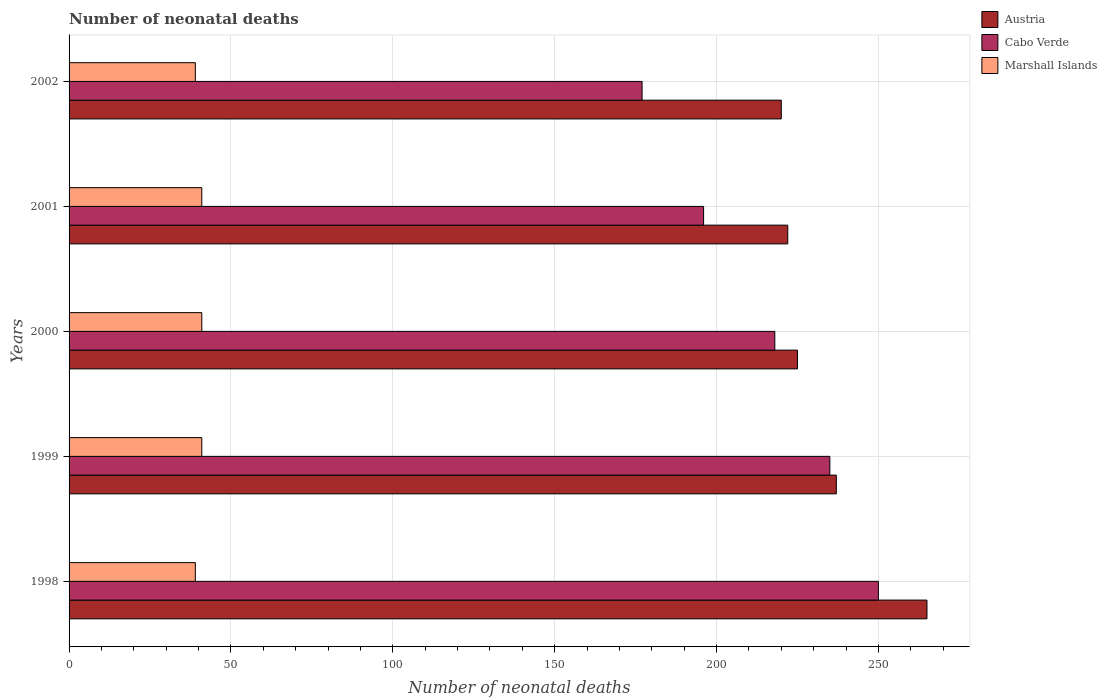How many different coloured bars are there?
Ensure brevity in your answer.  3. Are the number of bars per tick equal to the number of legend labels?
Offer a very short reply. Yes. Are the number of bars on each tick of the Y-axis equal?
Your response must be concise. Yes. How many bars are there on the 2nd tick from the top?
Provide a succinct answer. 3. How many bars are there on the 4th tick from the bottom?
Your answer should be compact. 3. What is the label of the 2nd group of bars from the top?
Ensure brevity in your answer.  2001. In how many cases, is the number of bars for a given year not equal to the number of legend labels?
Keep it short and to the point. 0. What is the number of neonatal deaths in in Cabo Verde in 1999?
Offer a very short reply. 235. Across all years, what is the maximum number of neonatal deaths in in Cabo Verde?
Offer a terse response. 250. Across all years, what is the minimum number of neonatal deaths in in Austria?
Make the answer very short. 220. In which year was the number of neonatal deaths in in Cabo Verde minimum?
Provide a short and direct response. 2002. What is the total number of neonatal deaths in in Marshall Islands in the graph?
Ensure brevity in your answer.  201. What is the difference between the number of neonatal deaths in in Cabo Verde in 2001 and that in 2002?
Your response must be concise. 19. What is the difference between the number of neonatal deaths in in Marshall Islands in 2000 and the number of neonatal deaths in in Austria in 1998?
Your answer should be very brief. -224. What is the average number of neonatal deaths in in Marshall Islands per year?
Give a very brief answer. 40.2. In the year 2001, what is the difference between the number of neonatal deaths in in Austria and number of neonatal deaths in in Marshall Islands?
Keep it short and to the point. 181. In how many years, is the number of neonatal deaths in in Cabo Verde greater than 190 ?
Make the answer very short. 4. What is the ratio of the number of neonatal deaths in in Austria in 2000 to that in 2001?
Give a very brief answer. 1.01. What is the difference between the highest and the second highest number of neonatal deaths in in Marshall Islands?
Keep it short and to the point. 0. What is the difference between the highest and the lowest number of neonatal deaths in in Austria?
Give a very brief answer. 45. In how many years, is the number of neonatal deaths in in Austria greater than the average number of neonatal deaths in in Austria taken over all years?
Ensure brevity in your answer.  2. What does the 2nd bar from the top in 2002 represents?
Make the answer very short. Cabo Verde. What does the 3rd bar from the bottom in 2001 represents?
Offer a terse response. Marshall Islands. Are all the bars in the graph horizontal?
Your response must be concise. Yes. How many years are there in the graph?
Offer a terse response. 5. What is the difference between two consecutive major ticks on the X-axis?
Your answer should be compact. 50. Are the values on the major ticks of X-axis written in scientific E-notation?
Provide a succinct answer. No. Does the graph contain grids?
Offer a terse response. Yes. Where does the legend appear in the graph?
Keep it short and to the point. Top right. How many legend labels are there?
Make the answer very short. 3. How are the legend labels stacked?
Your answer should be very brief. Vertical. What is the title of the graph?
Ensure brevity in your answer.  Number of neonatal deaths. What is the label or title of the X-axis?
Your answer should be very brief. Number of neonatal deaths. What is the Number of neonatal deaths in Austria in 1998?
Provide a succinct answer. 265. What is the Number of neonatal deaths of Cabo Verde in 1998?
Provide a succinct answer. 250. What is the Number of neonatal deaths of Austria in 1999?
Provide a short and direct response. 237. What is the Number of neonatal deaths of Cabo Verde in 1999?
Your answer should be very brief. 235. What is the Number of neonatal deaths in Austria in 2000?
Your response must be concise. 225. What is the Number of neonatal deaths of Cabo Verde in 2000?
Provide a succinct answer. 218. What is the Number of neonatal deaths in Austria in 2001?
Provide a succinct answer. 222. What is the Number of neonatal deaths of Cabo Verde in 2001?
Your answer should be very brief. 196. What is the Number of neonatal deaths of Austria in 2002?
Provide a succinct answer. 220. What is the Number of neonatal deaths in Cabo Verde in 2002?
Make the answer very short. 177. What is the Number of neonatal deaths in Marshall Islands in 2002?
Provide a short and direct response. 39. Across all years, what is the maximum Number of neonatal deaths in Austria?
Your answer should be compact. 265. Across all years, what is the maximum Number of neonatal deaths of Cabo Verde?
Offer a terse response. 250. Across all years, what is the minimum Number of neonatal deaths of Austria?
Keep it short and to the point. 220. Across all years, what is the minimum Number of neonatal deaths of Cabo Verde?
Your response must be concise. 177. What is the total Number of neonatal deaths in Austria in the graph?
Ensure brevity in your answer.  1169. What is the total Number of neonatal deaths in Cabo Verde in the graph?
Keep it short and to the point. 1076. What is the total Number of neonatal deaths of Marshall Islands in the graph?
Provide a short and direct response. 201. What is the difference between the Number of neonatal deaths in Austria in 1998 and that in 1999?
Make the answer very short. 28. What is the difference between the Number of neonatal deaths in Cabo Verde in 1998 and that in 1999?
Ensure brevity in your answer.  15. What is the difference between the Number of neonatal deaths of Marshall Islands in 1998 and that in 1999?
Offer a terse response. -2. What is the difference between the Number of neonatal deaths in Austria in 1998 and that in 2000?
Your answer should be very brief. 40. What is the difference between the Number of neonatal deaths of Marshall Islands in 1998 and that in 2000?
Ensure brevity in your answer.  -2. What is the difference between the Number of neonatal deaths of Austria in 1998 and that in 2001?
Your response must be concise. 43. What is the difference between the Number of neonatal deaths of Cabo Verde in 1998 and that in 2001?
Make the answer very short. 54. What is the difference between the Number of neonatal deaths of Cabo Verde in 1999 and that in 2000?
Make the answer very short. 17. What is the difference between the Number of neonatal deaths in Marshall Islands in 1999 and that in 2002?
Give a very brief answer. 2. What is the difference between the Number of neonatal deaths of Marshall Islands in 2000 and that in 2001?
Keep it short and to the point. 0. What is the difference between the Number of neonatal deaths in Austria in 2000 and that in 2002?
Your answer should be compact. 5. What is the difference between the Number of neonatal deaths of Marshall Islands in 2000 and that in 2002?
Your answer should be compact. 2. What is the difference between the Number of neonatal deaths in Cabo Verde in 2001 and that in 2002?
Ensure brevity in your answer.  19. What is the difference between the Number of neonatal deaths of Marshall Islands in 2001 and that in 2002?
Keep it short and to the point. 2. What is the difference between the Number of neonatal deaths of Austria in 1998 and the Number of neonatal deaths of Marshall Islands in 1999?
Offer a very short reply. 224. What is the difference between the Number of neonatal deaths of Cabo Verde in 1998 and the Number of neonatal deaths of Marshall Islands in 1999?
Provide a short and direct response. 209. What is the difference between the Number of neonatal deaths of Austria in 1998 and the Number of neonatal deaths of Marshall Islands in 2000?
Give a very brief answer. 224. What is the difference between the Number of neonatal deaths in Cabo Verde in 1998 and the Number of neonatal deaths in Marshall Islands in 2000?
Provide a short and direct response. 209. What is the difference between the Number of neonatal deaths in Austria in 1998 and the Number of neonatal deaths in Marshall Islands in 2001?
Offer a very short reply. 224. What is the difference between the Number of neonatal deaths of Cabo Verde in 1998 and the Number of neonatal deaths of Marshall Islands in 2001?
Provide a succinct answer. 209. What is the difference between the Number of neonatal deaths in Austria in 1998 and the Number of neonatal deaths in Cabo Verde in 2002?
Your answer should be very brief. 88. What is the difference between the Number of neonatal deaths of Austria in 1998 and the Number of neonatal deaths of Marshall Islands in 2002?
Give a very brief answer. 226. What is the difference between the Number of neonatal deaths of Cabo Verde in 1998 and the Number of neonatal deaths of Marshall Islands in 2002?
Give a very brief answer. 211. What is the difference between the Number of neonatal deaths in Austria in 1999 and the Number of neonatal deaths in Cabo Verde in 2000?
Ensure brevity in your answer.  19. What is the difference between the Number of neonatal deaths of Austria in 1999 and the Number of neonatal deaths of Marshall Islands in 2000?
Offer a terse response. 196. What is the difference between the Number of neonatal deaths of Cabo Verde in 1999 and the Number of neonatal deaths of Marshall Islands in 2000?
Your answer should be very brief. 194. What is the difference between the Number of neonatal deaths of Austria in 1999 and the Number of neonatal deaths of Marshall Islands in 2001?
Your response must be concise. 196. What is the difference between the Number of neonatal deaths of Cabo Verde in 1999 and the Number of neonatal deaths of Marshall Islands in 2001?
Offer a very short reply. 194. What is the difference between the Number of neonatal deaths of Austria in 1999 and the Number of neonatal deaths of Marshall Islands in 2002?
Your answer should be very brief. 198. What is the difference between the Number of neonatal deaths of Cabo Verde in 1999 and the Number of neonatal deaths of Marshall Islands in 2002?
Provide a short and direct response. 196. What is the difference between the Number of neonatal deaths in Austria in 2000 and the Number of neonatal deaths in Cabo Verde in 2001?
Your response must be concise. 29. What is the difference between the Number of neonatal deaths in Austria in 2000 and the Number of neonatal deaths in Marshall Islands in 2001?
Your response must be concise. 184. What is the difference between the Number of neonatal deaths of Cabo Verde in 2000 and the Number of neonatal deaths of Marshall Islands in 2001?
Keep it short and to the point. 177. What is the difference between the Number of neonatal deaths in Austria in 2000 and the Number of neonatal deaths in Marshall Islands in 2002?
Ensure brevity in your answer.  186. What is the difference between the Number of neonatal deaths in Cabo Verde in 2000 and the Number of neonatal deaths in Marshall Islands in 2002?
Offer a very short reply. 179. What is the difference between the Number of neonatal deaths of Austria in 2001 and the Number of neonatal deaths of Marshall Islands in 2002?
Give a very brief answer. 183. What is the difference between the Number of neonatal deaths in Cabo Verde in 2001 and the Number of neonatal deaths in Marshall Islands in 2002?
Provide a short and direct response. 157. What is the average Number of neonatal deaths of Austria per year?
Provide a succinct answer. 233.8. What is the average Number of neonatal deaths in Cabo Verde per year?
Keep it short and to the point. 215.2. What is the average Number of neonatal deaths in Marshall Islands per year?
Your answer should be compact. 40.2. In the year 1998, what is the difference between the Number of neonatal deaths in Austria and Number of neonatal deaths in Cabo Verde?
Provide a succinct answer. 15. In the year 1998, what is the difference between the Number of neonatal deaths of Austria and Number of neonatal deaths of Marshall Islands?
Make the answer very short. 226. In the year 1998, what is the difference between the Number of neonatal deaths of Cabo Verde and Number of neonatal deaths of Marshall Islands?
Provide a succinct answer. 211. In the year 1999, what is the difference between the Number of neonatal deaths of Austria and Number of neonatal deaths of Cabo Verde?
Offer a terse response. 2. In the year 1999, what is the difference between the Number of neonatal deaths of Austria and Number of neonatal deaths of Marshall Islands?
Your response must be concise. 196. In the year 1999, what is the difference between the Number of neonatal deaths of Cabo Verde and Number of neonatal deaths of Marshall Islands?
Keep it short and to the point. 194. In the year 2000, what is the difference between the Number of neonatal deaths in Austria and Number of neonatal deaths in Marshall Islands?
Provide a succinct answer. 184. In the year 2000, what is the difference between the Number of neonatal deaths of Cabo Verde and Number of neonatal deaths of Marshall Islands?
Your response must be concise. 177. In the year 2001, what is the difference between the Number of neonatal deaths of Austria and Number of neonatal deaths of Marshall Islands?
Provide a succinct answer. 181. In the year 2001, what is the difference between the Number of neonatal deaths of Cabo Verde and Number of neonatal deaths of Marshall Islands?
Your answer should be compact. 155. In the year 2002, what is the difference between the Number of neonatal deaths of Austria and Number of neonatal deaths of Cabo Verde?
Provide a succinct answer. 43. In the year 2002, what is the difference between the Number of neonatal deaths of Austria and Number of neonatal deaths of Marshall Islands?
Make the answer very short. 181. In the year 2002, what is the difference between the Number of neonatal deaths of Cabo Verde and Number of neonatal deaths of Marshall Islands?
Give a very brief answer. 138. What is the ratio of the Number of neonatal deaths in Austria in 1998 to that in 1999?
Offer a terse response. 1.12. What is the ratio of the Number of neonatal deaths in Cabo Verde in 1998 to that in 1999?
Your answer should be compact. 1.06. What is the ratio of the Number of neonatal deaths in Marshall Islands in 1998 to that in 1999?
Provide a short and direct response. 0.95. What is the ratio of the Number of neonatal deaths of Austria in 1998 to that in 2000?
Your answer should be very brief. 1.18. What is the ratio of the Number of neonatal deaths of Cabo Verde in 1998 to that in 2000?
Offer a terse response. 1.15. What is the ratio of the Number of neonatal deaths of Marshall Islands in 1998 to that in 2000?
Your answer should be very brief. 0.95. What is the ratio of the Number of neonatal deaths of Austria in 1998 to that in 2001?
Make the answer very short. 1.19. What is the ratio of the Number of neonatal deaths of Cabo Verde in 1998 to that in 2001?
Your answer should be compact. 1.28. What is the ratio of the Number of neonatal deaths of Marshall Islands in 1998 to that in 2001?
Keep it short and to the point. 0.95. What is the ratio of the Number of neonatal deaths of Austria in 1998 to that in 2002?
Offer a very short reply. 1.2. What is the ratio of the Number of neonatal deaths of Cabo Verde in 1998 to that in 2002?
Provide a short and direct response. 1.41. What is the ratio of the Number of neonatal deaths in Austria in 1999 to that in 2000?
Your response must be concise. 1.05. What is the ratio of the Number of neonatal deaths of Cabo Verde in 1999 to that in 2000?
Keep it short and to the point. 1.08. What is the ratio of the Number of neonatal deaths in Marshall Islands in 1999 to that in 2000?
Provide a succinct answer. 1. What is the ratio of the Number of neonatal deaths of Austria in 1999 to that in 2001?
Give a very brief answer. 1.07. What is the ratio of the Number of neonatal deaths of Cabo Verde in 1999 to that in 2001?
Make the answer very short. 1.2. What is the ratio of the Number of neonatal deaths of Marshall Islands in 1999 to that in 2001?
Keep it short and to the point. 1. What is the ratio of the Number of neonatal deaths in Austria in 1999 to that in 2002?
Your answer should be compact. 1.08. What is the ratio of the Number of neonatal deaths in Cabo Verde in 1999 to that in 2002?
Make the answer very short. 1.33. What is the ratio of the Number of neonatal deaths of Marshall Islands in 1999 to that in 2002?
Give a very brief answer. 1.05. What is the ratio of the Number of neonatal deaths in Austria in 2000 to that in 2001?
Make the answer very short. 1.01. What is the ratio of the Number of neonatal deaths of Cabo Verde in 2000 to that in 2001?
Give a very brief answer. 1.11. What is the ratio of the Number of neonatal deaths in Austria in 2000 to that in 2002?
Offer a very short reply. 1.02. What is the ratio of the Number of neonatal deaths in Cabo Verde in 2000 to that in 2002?
Keep it short and to the point. 1.23. What is the ratio of the Number of neonatal deaths of Marshall Islands in 2000 to that in 2002?
Make the answer very short. 1.05. What is the ratio of the Number of neonatal deaths in Austria in 2001 to that in 2002?
Offer a terse response. 1.01. What is the ratio of the Number of neonatal deaths in Cabo Verde in 2001 to that in 2002?
Your response must be concise. 1.11. What is the ratio of the Number of neonatal deaths of Marshall Islands in 2001 to that in 2002?
Ensure brevity in your answer.  1.05. What is the difference between the highest and the second highest Number of neonatal deaths in Cabo Verde?
Ensure brevity in your answer.  15. What is the difference between the highest and the lowest Number of neonatal deaths in Cabo Verde?
Make the answer very short. 73. 